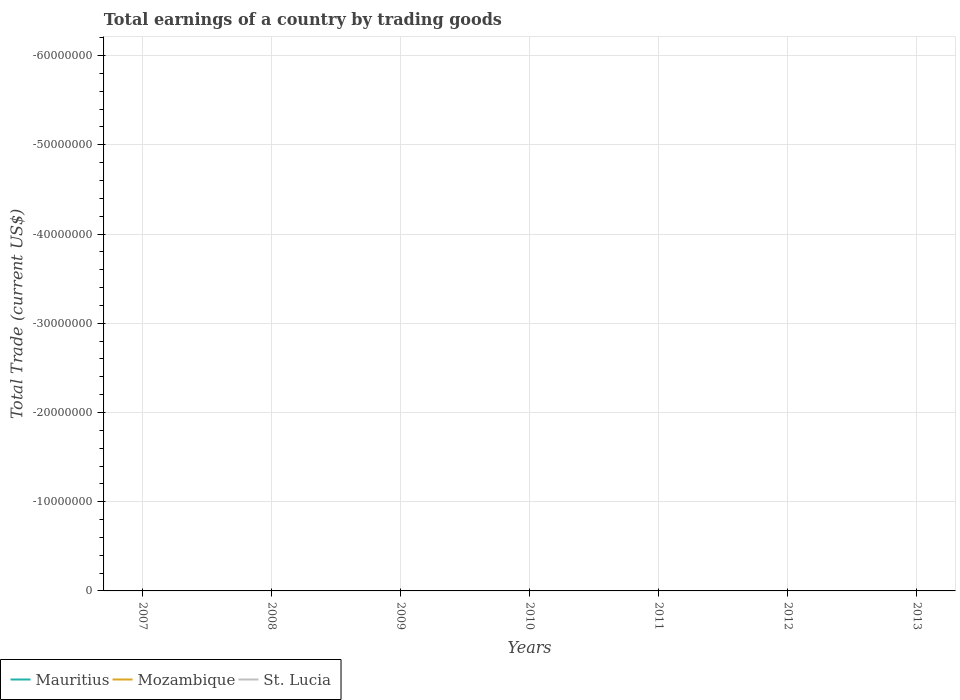How many different coloured lines are there?
Ensure brevity in your answer.  0. Is the number of lines equal to the number of legend labels?
Your answer should be very brief. No. What is the difference between the highest and the lowest total earnings in Mozambique?
Offer a very short reply. 0. Is the total earnings in Mozambique strictly greater than the total earnings in St. Lucia over the years?
Your answer should be compact. No. How many years are there in the graph?
Provide a short and direct response. 7. What is the difference between two consecutive major ticks on the Y-axis?
Provide a short and direct response. 1.00e+07. Does the graph contain any zero values?
Ensure brevity in your answer.  Yes. How many legend labels are there?
Provide a short and direct response. 3. How are the legend labels stacked?
Keep it short and to the point. Horizontal. What is the title of the graph?
Your answer should be compact. Total earnings of a country by trading goods. Does "Uganda" appear as one of the legend labels in the graph?
Your answer should be very brief. No. What is the label or title of the Y-axis?
Keep it short and to the point. Total Trade (current US$). What is the Total Trade (current US$) of Mozambique in 2007?
Give a very brief answer. 0. What is the Total Trade (current US$) in St. Lucia in 2007?
Your answer should be very brief. 0. What is the Total Trade (current US$) in St. Lucia in 2008?
Make the answer very short. 0. What is the Total Trade (current US$) of Mauritius in 2010?
Ensure brevity in your answer.  0. What is the Total Trade (current US$) in St. Lucia in 2010?
Provide a succinct answer. 0. What is the Total Trade (current US$) in Mauritius in 2011?
Provide a succinct answer. 0. What is the Total Trade (current US$) in Mozambique in 2011?
Provide a short and direct response. 0. What is the Total Trade (current US$) in Mauritius in 2012?
Your answer should be compact. 0. What is the Total Trade (current US$) in Mozambique in 2012?
Provide a short and direct response. 0. What is the Total Trade (current US$) of Mauritius in 2013?
Provide a succinct answer. 0. What is the Total Trade (current US$) of St. Lucia in 2013?
Give a very brief answer. 0. What is the total Total Trade (current US$) in Mauritius in the graph?
Your response must be concise. 0. What is the total Total Trade (current US$) of Mozambique in the graph?
Your answer should be very brief. 0. What is the total Total Trade (current US$) in St. Lucia in the graph?
Offer a terse response. 0. What is the average Total Trade (current US$) in Mauritius per year?
Your response must be concise. 0. What is the average Total Trade (current US$) in St. Lucia per year?
Offer a terse response. 0. 